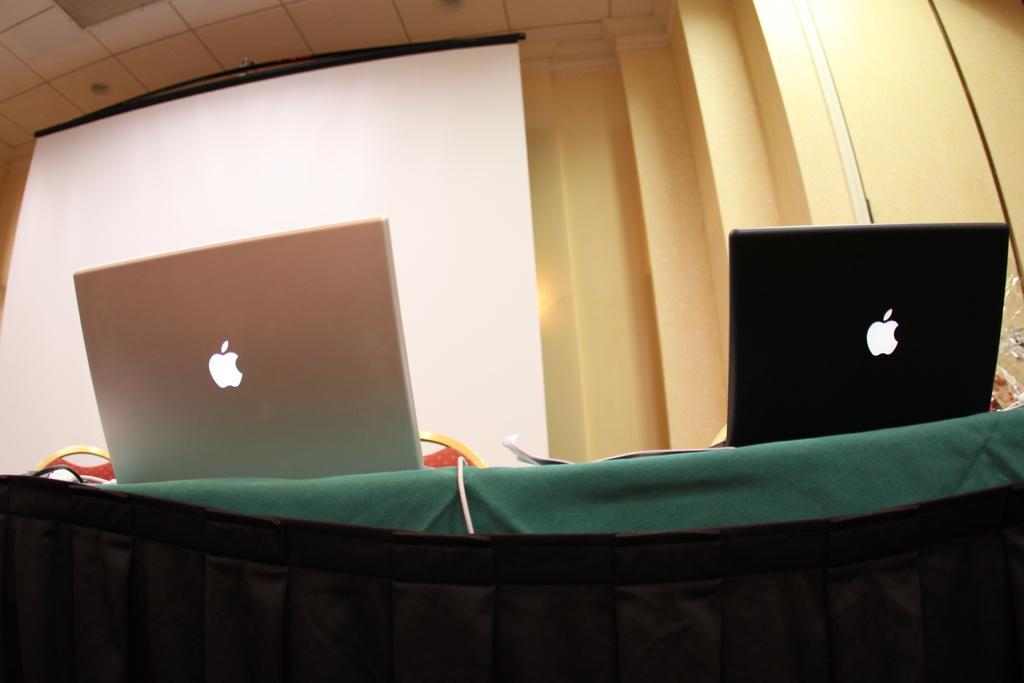Describe this image in one or two sentences. In this image there is a table, on that table there are two apple laptops, in the background there is a screen and a wall. 